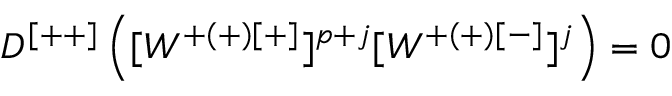Convert formula to latex. <formula><loc_0><loc_0><loc_500><loc_500>D ^ { [ + + ] } \left ( [ W ^ { + ( + ) [ + ] } ] ^ { p + j } [ W ^ { + ( + ) [ - ] } ] ^ { j } \right ) = 0</formula> 